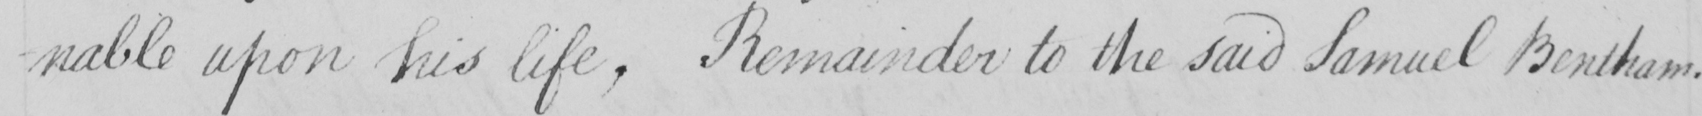Transcribe the text shown in this historical manuscript line. -nable upon his life , Remainder to the said Samuel Bentham . 